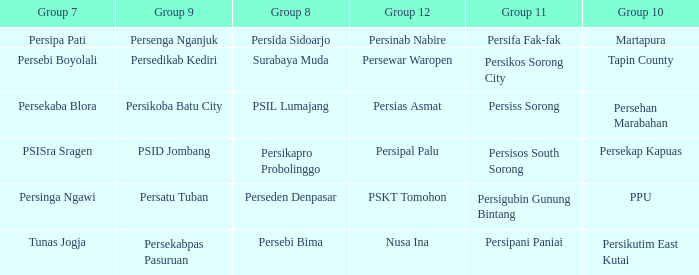Who played in group 8 when Persinab Nabire played in Group 12? Persida Sidoarjo. 